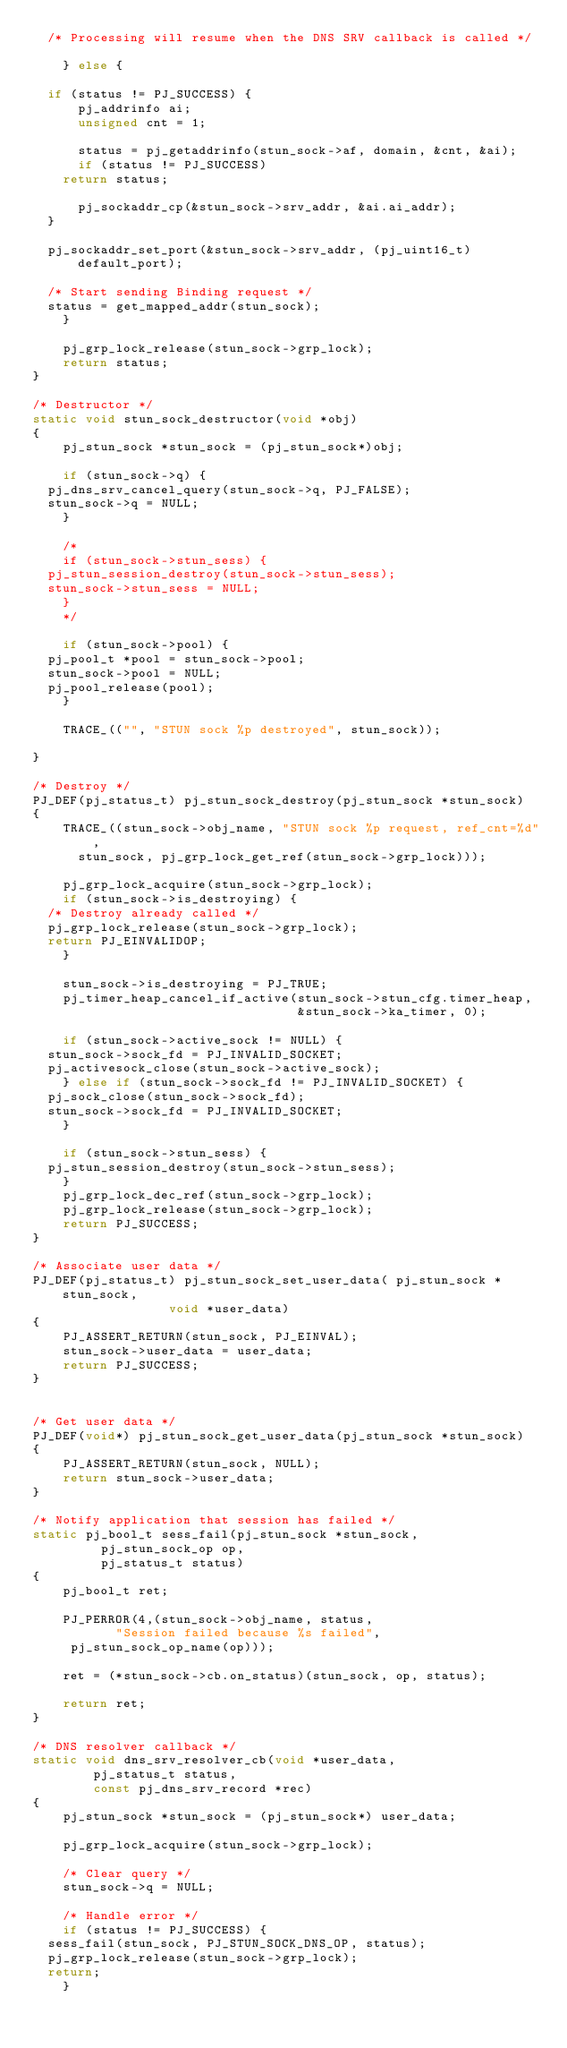<code> <loc_0><loc_0><loc_500><loc_500><_C_>	/* Processing will resume when the DNS SRV callback is called */

    } else {

	if (status != PJ_SUCCESS) {
	    pj_addrinfo ai;
	    unsigned cnt = 1;

	    status = pj_getaddrinfo(stun_sock->af, domain, &cnt, &ai);
	    if (status != PJ_SUCCESS)
		return status;

	    pj_sockaddr_cp(&stun_sock->srv_addr, &ai.ai_addr);
	}

	pj_sockaddr_set_port(&stun_sock->srv_addr, (pj_uint16_t)default_port);

	/* Start sending Binding request */
	status = get_mapped_addr(stun_sock);
    }

    pj_grp_lock_release(stun_sock->grp_lock);
    return status;
}

/* Destructor */
static void stun_sock_destructor(void *obj)
{
    pj_stun_sock *stun_sock = (pj_stun_sock*)obj;

    if (stun_sock->q) {
	pj_dns_srv_cancel_query(stun_sock->q, PJ_FALSE);
	stun_sock->q = NULL;
    }

    /*
    if (stun_sock->stun_sess) {
	pj_stun_session_destroy(stun_sock->stun_sess);
	stun_sock->stun_sess = NULL;
    }
    */

    if (stun_sock->pool) {
	pj_pool_t *pool = stun_sock->pool;
	stun_sock->pool = NULL;
	pj_pool_release(pool);
    }

    TRACE_(("", "STUN sock %p destroyed", stun_sock));

}

/* Destroy */
PJ_DEF(pj_status_t) pj_stun_sock_destroy(pj_stun_sock *stun_sock)
{
    TRACE_((stun_sock->obj_name, "STUN sock %p request, ref_cnt=%d",
	    stun_sock, pj_grp_lock_get_ref(stun_sock->grp_lock)));

    pj_grp_lock_acquire(stun_sock->grp_lock);
    if (stun_sock->is_destroying) {
	/* Destroy already called */
	pj_grp_lock_release(stun_sock->grp_lock);
	return PJ_EINVALIDOP;
    }

    stun_sock->is_destroying = PJ_TRUE;
    pj_timer_heap_cancel_if_active(stun_sock->stun_cfg.timer_heap,
                                   &stun_sock->ka_timer, 0);

    if (stun_sock->active_sock != NULL) {
	stun_sock->sock_fd = PJ_INVALID_SOCKET;
	pj_activesock_close(stun_sock->active_sock);
    } else if (stun_sock->sock_fd != PJ_INVALID_SOCKET) {
	pj_sock_close(stun_sock->sock_fd);
	stun_sock->sock_fd = PJ_INVALID_SOCKET;
    }

    if (stun_sock->stun_sess) {
	pj_stun_session_destroy(stun_sock->stun_sess);
    }
    pj_grp_lock_dec_ref(stun_sock->grp_lock);
    pj_grp_lock_release(stun_sock->grp_lock);
    return PJ_SUCCESS;
}

/* Associate user data */
PJ_DEF(pj_status_t) pj_stun_sock_set_user_data( pj_stun_sock *stun_sock,
					        void *user_data)
{
    PJ_ASSERT_RETURN(stun_sock, PJ_EINVAL);
    stun_sock->user_data = user_data;
    return PJ_SUCCESS;
}


/* Get user data */
PJ_DEF(void*) pj_stun_sock_get_user_data(pj_stun_sock *stun_sock)
{
    PJ_ASSERT_RETURN(stun_sock, NULL);
    return stun_sock->user_data;
}

/* Notify application that session has failed */
static pj_bool_t sess_fail(pj_stun_sock *stun_sock, 
			   pj_stun_sock_op op,
			   pj_status_t status)
{
    pj_bool_t ret;

    PJ_PERROR(4,(stun_sock->obj_name, status, 
	         "Session failed because %s failed",
		 pj_stun_sock_op_name(op)));

    ret = (*stun_sock->cb.on_status)(stun_sock, op, status);

    return ret;
}

/* DNS resolver callback */
static void dns_srv_resolver_cb(void *user_data,
				pj_status_t status,
				const pj_dns_srv_record *rec)
{
    pj_stun_sock *stun_sock = (pj_stun_sock*) user_data;

    pj_grp_lock_acquire(stun_sock->grp_lock);

    /* Clear query */
    stun_sock->q = NULL;

    /* Handle error */
    if (status != PJ_SUCCESS) {
	sess_fail(stun_sock, PJ_STUN_SOCK_DNS_OP, status);
	pj_grp_lock_release(stun_sock->grp_lock);
	return;
    }
</code> 